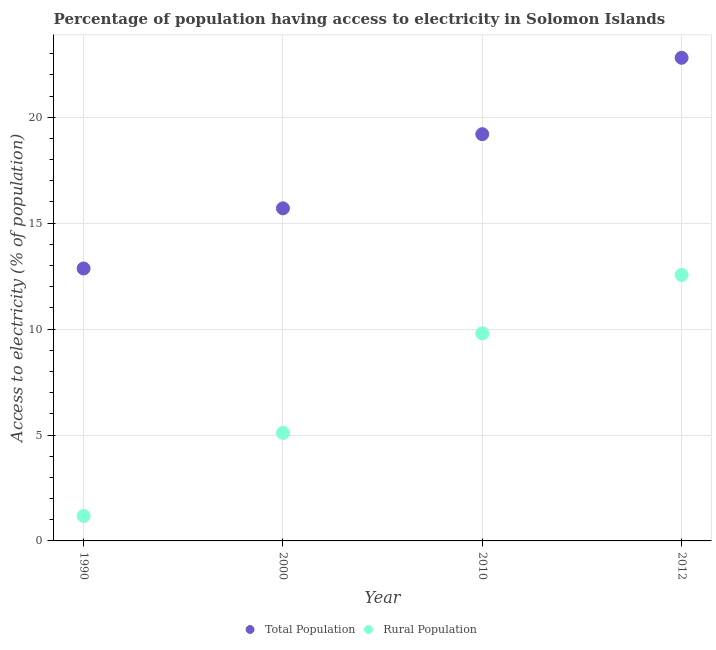How many different coloured dotlines are there?
Your answer should be very brief. 2. What is the percentage of rural population having access to electricity in 2010?
Your answer should be very brief. 9.8. Across all years, what is the maximum percentage of rural population having access to electricity?
Provide a succinct answer. 12.55. Across all years, what is the minimum percentage of population having access to electricity?
Your answer should be very brief. 12.86. In which year was the percentage of rural population having access to electricity maximum?
Offer a very short reply. 2012. What is the total percentage of population having access to electricity in the graph?
Make the answer very short. 70.57. What is the difference between the percentage of rural population having access to electricity in 1990 and that in 2000?
Keep it short and to the point. -3.92. What is the difference between the percentage of population having access to electricity in 2012 and the percentage of rural population having access to electricity in 1990?
Give a very brief answer. 21.63. What is the average percentage of rural population having access to electricity per year?
Your answer should be compact. 7.16. In the year 2000, what is the difference between the percentage of population having access to electricity and percentage of rural population having access to electricity?
Your response must be concise. 10.6. In how many years, is the percentage of rural population having access to electricity greater than 22 %?
Make the answer very short. 0. What is the ratio of the percentage of population having access to electricity in 2010 to that in 2012?
Keep it short and to the point. 0.84. Is the difference between the percentage of population having access to electricity in 1990 and 2010 greater than the difference between the percentage of rural population having access to electricity in 1990 and 2010?
Make the answer very short. Yes. What is the difference between the highest and the second highest percentage of population having access to electricity?
Give a very brief answer. 3.61. What is the difference between the highest and the lowest percentage of population having access to electricity?
Make the answer very short. 9.95. Does the percentage of rural population having access to electricity monotonically increase over the years?
Your response must be concise. Yes. Is the percentage of population having access to electricity strictly greater than the percentage of rural population having access to electricity over the years?
Offer a very short reply. Yes. Is the percentage of rural population having access to electricity strictly less than the percentage of population having access to electricity over the years?
Provide a short and direct response. Yes. How many years are there in the graph?
Provide a short and direct response. 4. Are the values on the major ticks of Y-axis written in scientific E-notation?
Provide a short and direct response. No. Does the graph contain grids?
Offer a terse response. Yes. How many legend labels are there?
Provide a succinct answer. 2. How are the legend labels stacked?
Provide a short and direct response. Horizontal. What is the title of the graph?
Give a very brief answer. Percentage of population having access to electricity in Solomon Islands. What is the label or title of the X-axis?
Provide a succinct answer. Year. What is the label or title of the Y-axis?
Keep it short and to the point. Access to electricity (% of population). What is the Access to electricity (% of population) of Total Population in 1990?
Your response must be concise. 12.86. What is the Access to electricity (% of population) in Rural Population in 1990?
Make the answer very short. 1.18. What is the Access to electricity (% of population) of Total Population in 2000?
Provide a succinct answer. 15.7. What is the Access to electricity (% of population) in Rural Population in 2000?
Provide a short and direct response. 5.1. What is the Access to electricity (% of population) of Rural Population in 2010?
Offer a very short reply. 9.8. What is the Access to electricity (% of population) of Total Population in 2012?
Your answer should be compact. 22.81. What is the Access to electricity (% of population) in Rural Population in 2012?
Offer a very short reply. 12.55. Across all years, what is the maximum Access to electricity (% of population) in Total Population?
Provide a short and direct response. 22.81. Across all years, what is the maximum Access to electricity (% of population) in Rural Population?
Your answer should be very brief. 12.55. Across all years, what is the minimum Access to electricity (% of population) of Total Population?
Keep it short and to the point. 12.86. Across all years, what is the minimum Access to electricity (% of population) in Rural Population?
Keep it short and to the point. 1.18. What is the total Access to electricity (% of population) in Total Population in the graph?
Your response must be concise. 70.57. What is the total Access to electricity (% of population) of Rural Population in the graph?
Your answer should be very brief. 28.63. What is the difference between the Access to electricity (% of population) in Total Population in 1990 and that in 2000?
Keep it short and to the point. -2.84. What is the difference between the Access to electricity (% of population) of Rural Population in 1990 and that in 2000?
Offer a terse response. -3.92. What is the difference between the Access to electricity (% of population) in Total Population in 1990 and that in 2010?
Your answer should be very brief. -6.34. What is the difference between the Access to electricity (% of population) in Rural Population in 1990 and that in 2010?
Your answer should be very brief. -8.62. What is the difference between the Access to electricity (% of population) in Total Population in 1990 and that in 2012?
Provide a short and direct response. -9.95. What is the difference between the Access to electricity (% of population) of Rural Population in 1990 and that in 2012?
Ensure brevity in your answer.  -11.38. What is the difference between the Access to electricity (% of population) in Total Population in 2000 and that in 2010?
Provide a short and direct response. -3.5. What is the difference between the Access to electricity (% of population) of Total Population in 2000 and that in 2012?
Your answer should be compact. -7.11. What is the difference between the Access to electricity (% of population) in Rural Population in 2000 and that in 2012?
Your answer should be compact. -7.45. What is the difference between the Access to electricity (% of population) of Total Population in 2010 and that in 2012?
Give a very brief answer. -3.61. What is the difference between the Access to electricity (% of population) in Rural Population in 2010 and that in 2012?
Your answer should be very brief. -2.75. What is the difference between the Access to electricity (% of population) of Total Population in 1990 and the Access to electricity (% of population) of Rural Population in 2000?
Your answer should be very brief. 7.76. What is the difference between the Access to electricity (% of population) of Total Population in 1990 and the Access to electricity (% of population) of Rural Population in 2010?
Offer a terse response. 3.06. What is the difference between the Access to electricity (% of population) of Total Population in 1990 and the Access to electricity (% of population) of Rural Population in 2012?
Keep it short and to the point. 0.31. What is the difference between the Access to electricity (% of population) of Total Population in 2000 and the Access to electricity (% of population) of Rural Population in 2010?
Make the answer very short. 5.9. What is the difference between the Access to electricity (% of population) of Total Population in 2000 and the Access to electricity (% of population) of Rural Population in 2012?
Make the answer very short. 3.15. What is the difference between the Access to electricity (% of population) in Total Population in 2010 and the Access to electricity (% of population) in Rural Population in 2012?
Make the answer very short. 6.65. What is the average Access to electricity (% of population) of Total Population per year?
Provide a short and direct response. 17.64. What is the average Access to electricity (% of population) of Rural Population per year?
Your answer should be very brief. 7.16. In the year 1990, what is the difference between the Access to electricity (% of population) in Total Population and Access to electricity (% of population) in Rural Population?
Your response must be concise. 11.68. In the year 2012, what is the difference between the Access to electricity (% of population) in Total Population and Access to electricity (% of population) in Rural Population?
Give a very brief answer. 10.25. What is the ratio of the Access to electricity (% of population) in Total Population in 1990 to that in 2000?
Offer a very short reply. 0.82. What is the ratio of the Access to electricity (% of population) of Rural Population in 1990 to that in 2000?
Make the answer very short. 0.23. What is the ratio of the Access to electricity (% of population) of Total Population in 1990 to that in 2010?
Your answer should be compact. 0.67. What is the ratio of the Access to electricity (% of population) of Rural Population in 1990 to that in 2010?
Keep it short and to the point. 0.12. What is the ratio of the Access to electricity (% of population) of Total Population in 1990 to that in 2012?
Give a very brief answer. 0.56. What is the ratio of the Access to electricity (% of population) in Rural Population in 1990 to that in 2012?
Keep it short and to the point. 0.09. What is the ratio of the Access to electricity (% of population) of Total Population in 2000 to that in 2010?
Your answer should be compact. 0.82. What is the ratio of the Access to electricity (% of population) of Rural Population in 2000 to that in 2010?
Your answer should be very brief. 0.52. What is the ratio of the Access to electricity (% of population) in Total Population in 2000 to that in 2012?
Provide a short and direct response. 0.69. What is the ratio of the Access to electricity (% of population) in Rural Population in 2000 to that in 2012?
Your answer should be compact. 0.41. What is the ratio of the Access to electricity (% of population) in Total Population in 2010 to that in 2012?
Your answer should be compact. 0.84. What is the ratio of the Access to electricity (% of population) of Rural Population in 2010 to that in 2012?
Keep it short and to the point. 0.78. What is the difference between the highest and the second highest Access to electricity (% of population) in Total Population?
Your answer should be compact. 3.61. What is the difference between the highest and the second highest Access to electricity (% of population) of Rural Population?
Offer a very short reply. 2.75. What is the difference between the highest and the lowest Access to electricity (% of population) of Total Population?
Ensure brevity in your answer.  9.95. What is the difference between the highest and the lowest Access to electricity (% of population) in Rural Population?
Your answer should be compact. 11.38. 